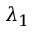<formula> <loc_0><loc_0><loc_500><loc_500>\lambda _ { 1 }</formula> 